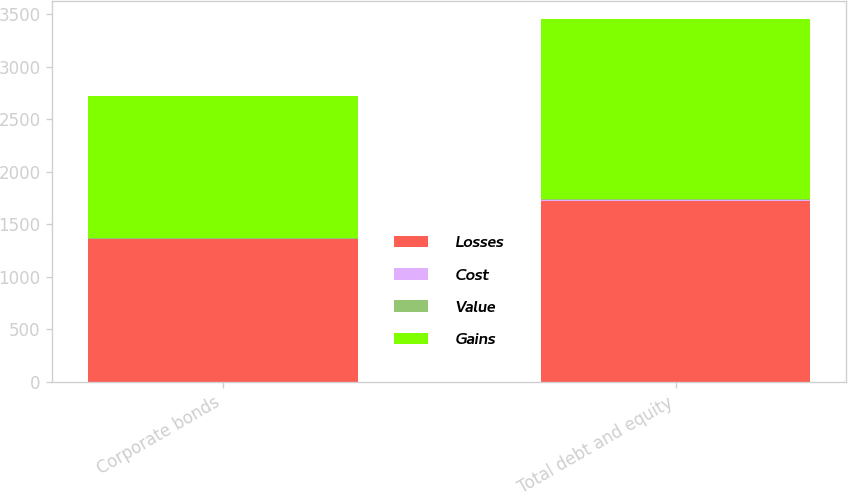<chart> <loc_0><loc_0><loc_500><loc_500><stacked_bar_chart><ecel><fcel>Corporate bonds<fcel>Total debt and equity<nl><fcel>Losses<fcel>1359<fcel>1725<nl><fcel>Cost<fcel>2<fcel>2<nl><fcel>Value<fcel>8<fcel>9<nl><fcel>Gains<fcel>1353<fcel>1718<nl></chart> 